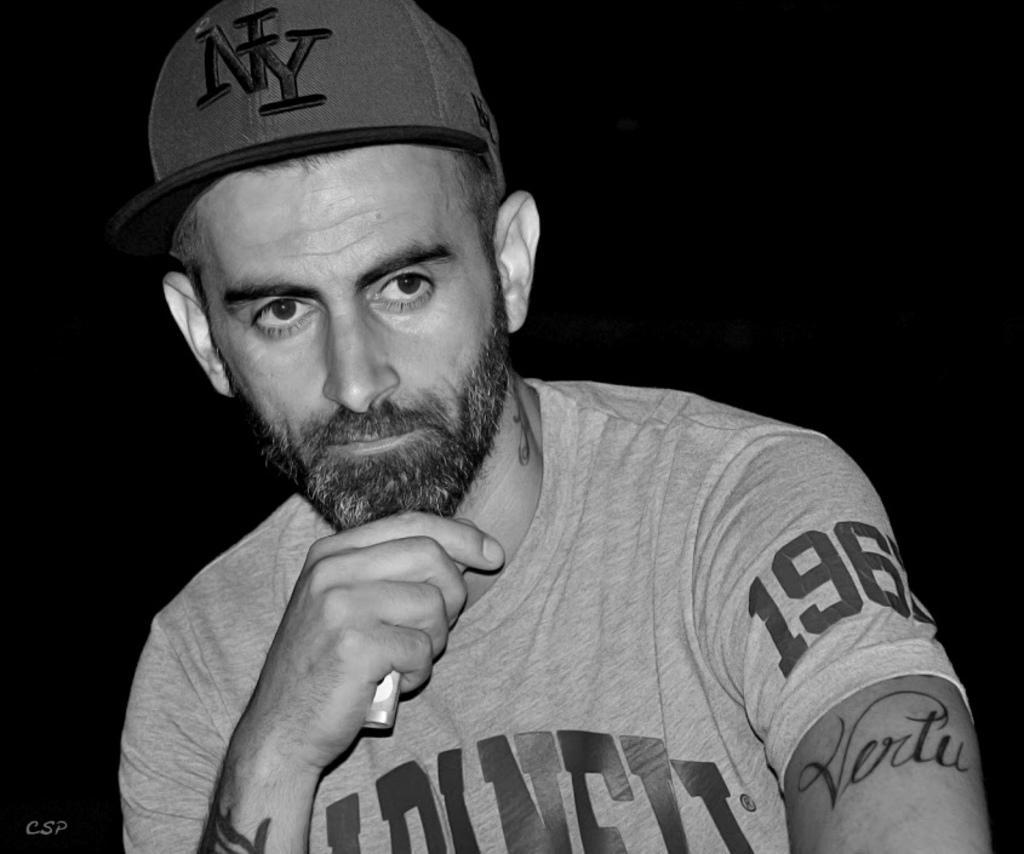Can you describe this image briefly? Black and white picture. This person wore cap and holding an object. Background it is dark. Here we can see watermark. On this person hands and neck there are tattoos. 